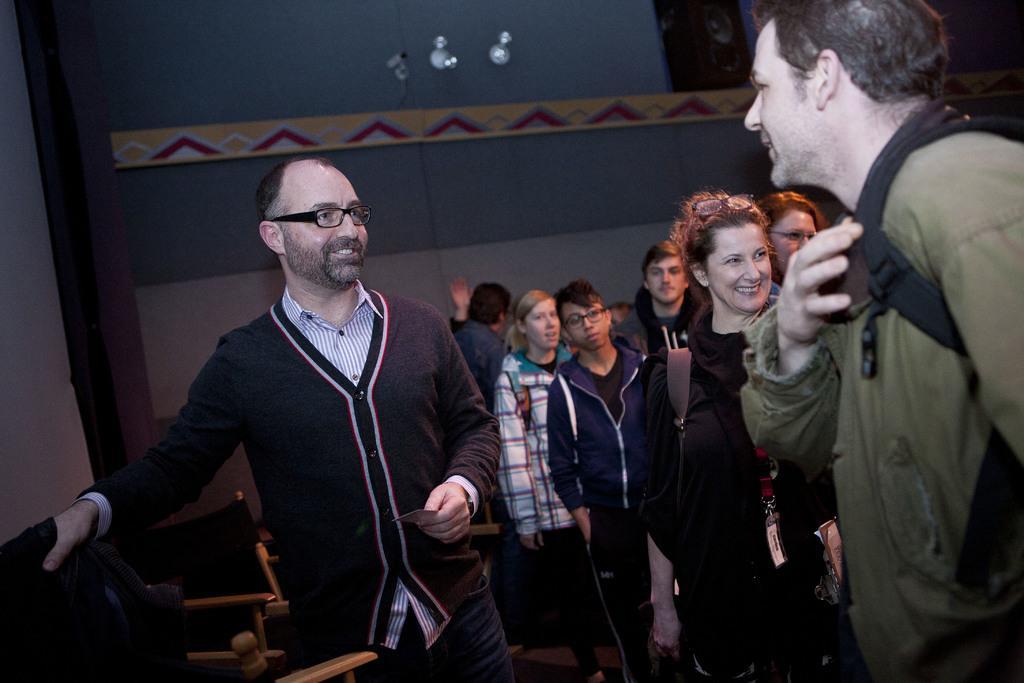Could you give a brief overview of what you see in this image? In the middle, we see a man is standing. He is wearing the spectacles and he is smiling. He is holding a card in his hands. Beside him, we see the chairs. On the right side, we see the people are standing. The man and the woman in front of the picture are smiling. In the background, we see a wall. At the top, we see the lights and we see a speaker box is placed on the yellow color shelf like thing. 